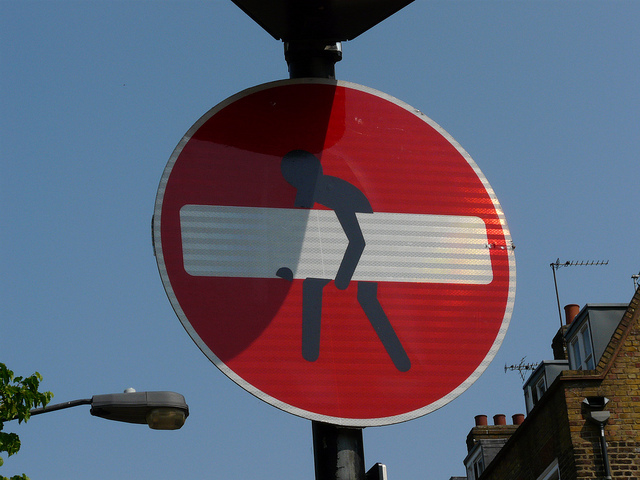<image>What two word phrase does the picture mean? It is ambiguous what two word phrase the picture means. It could be 'heavy lifting', 'no crossing', 'no entry', 'working', 'surfer crossing', 'no skateboarding', among others. What two word phrase does the picture mean? I am not sure what two word phrase the picture means. It can be 'no crossing', 'no entry', or 'idk'. 